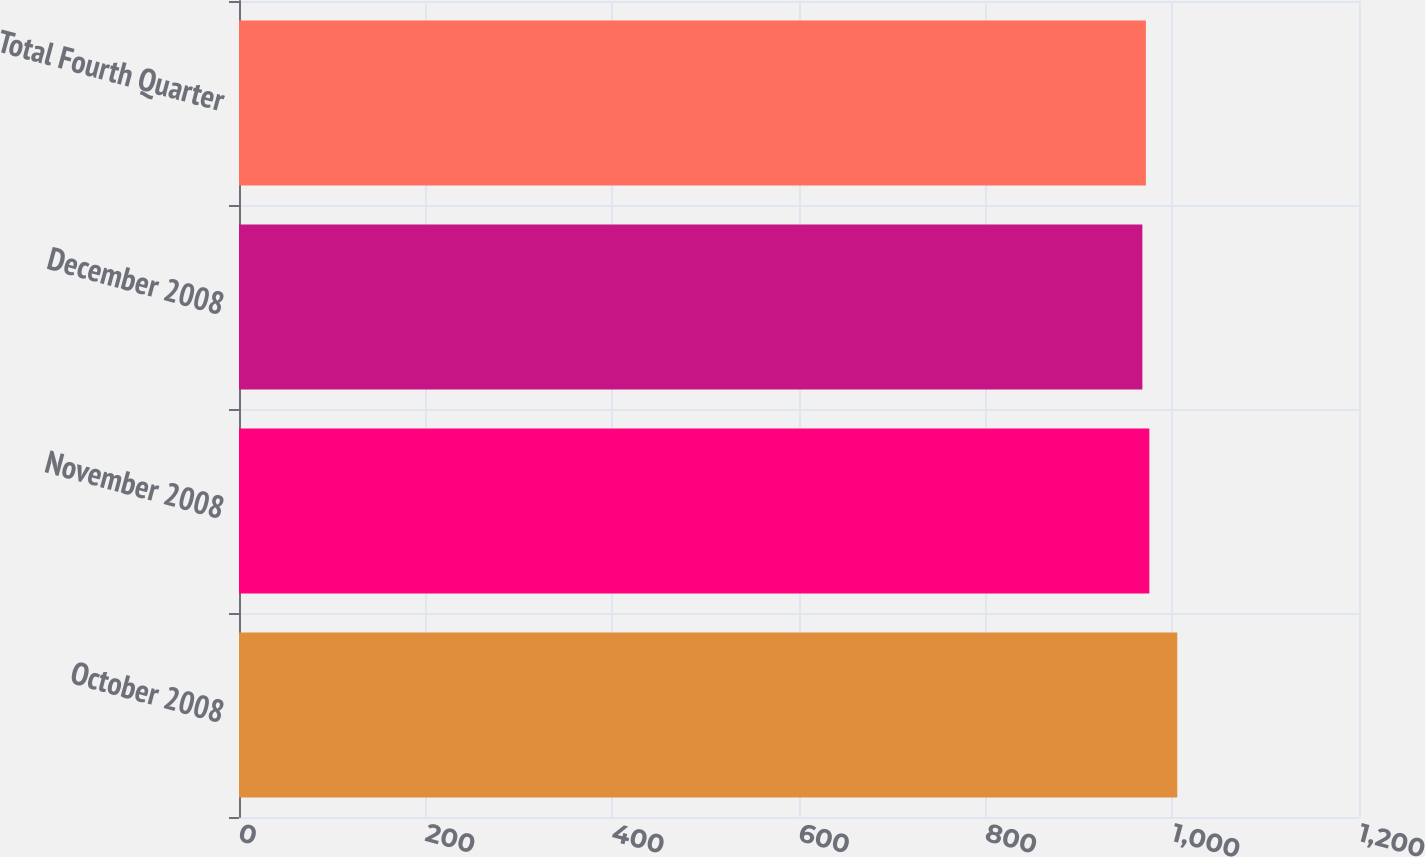<chart> <loc_0><loc_0><loc_500><loc_500><bar_chart><fcel>October 2008<fcel>November 2008<fcel>December 2008<fcel>Total Fourth Quarter<nl><fcel>1005.3<fcel>975.38<fcel>967.9<fcel>971.64<nl></chart> 